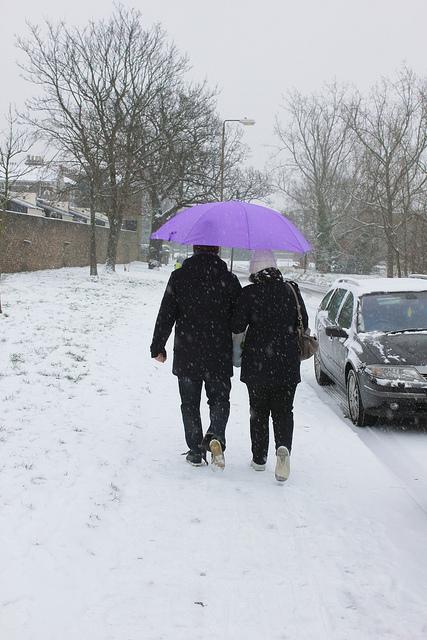What are these two people walking under?
Concise answer only. Umbrella. Is it a rainy day?
Quick response, please. No. Where is the car parked?
Give a very brief answer. Street. 